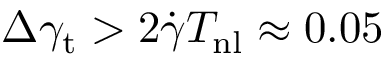Convert formula to latex. <formula><loc_0><loc_0><loc_500><loc_500>\Delta \gamma _ { t } > 2 \dot { \gamma } T _ { n l } \approx 0 . 0 5</formula> 